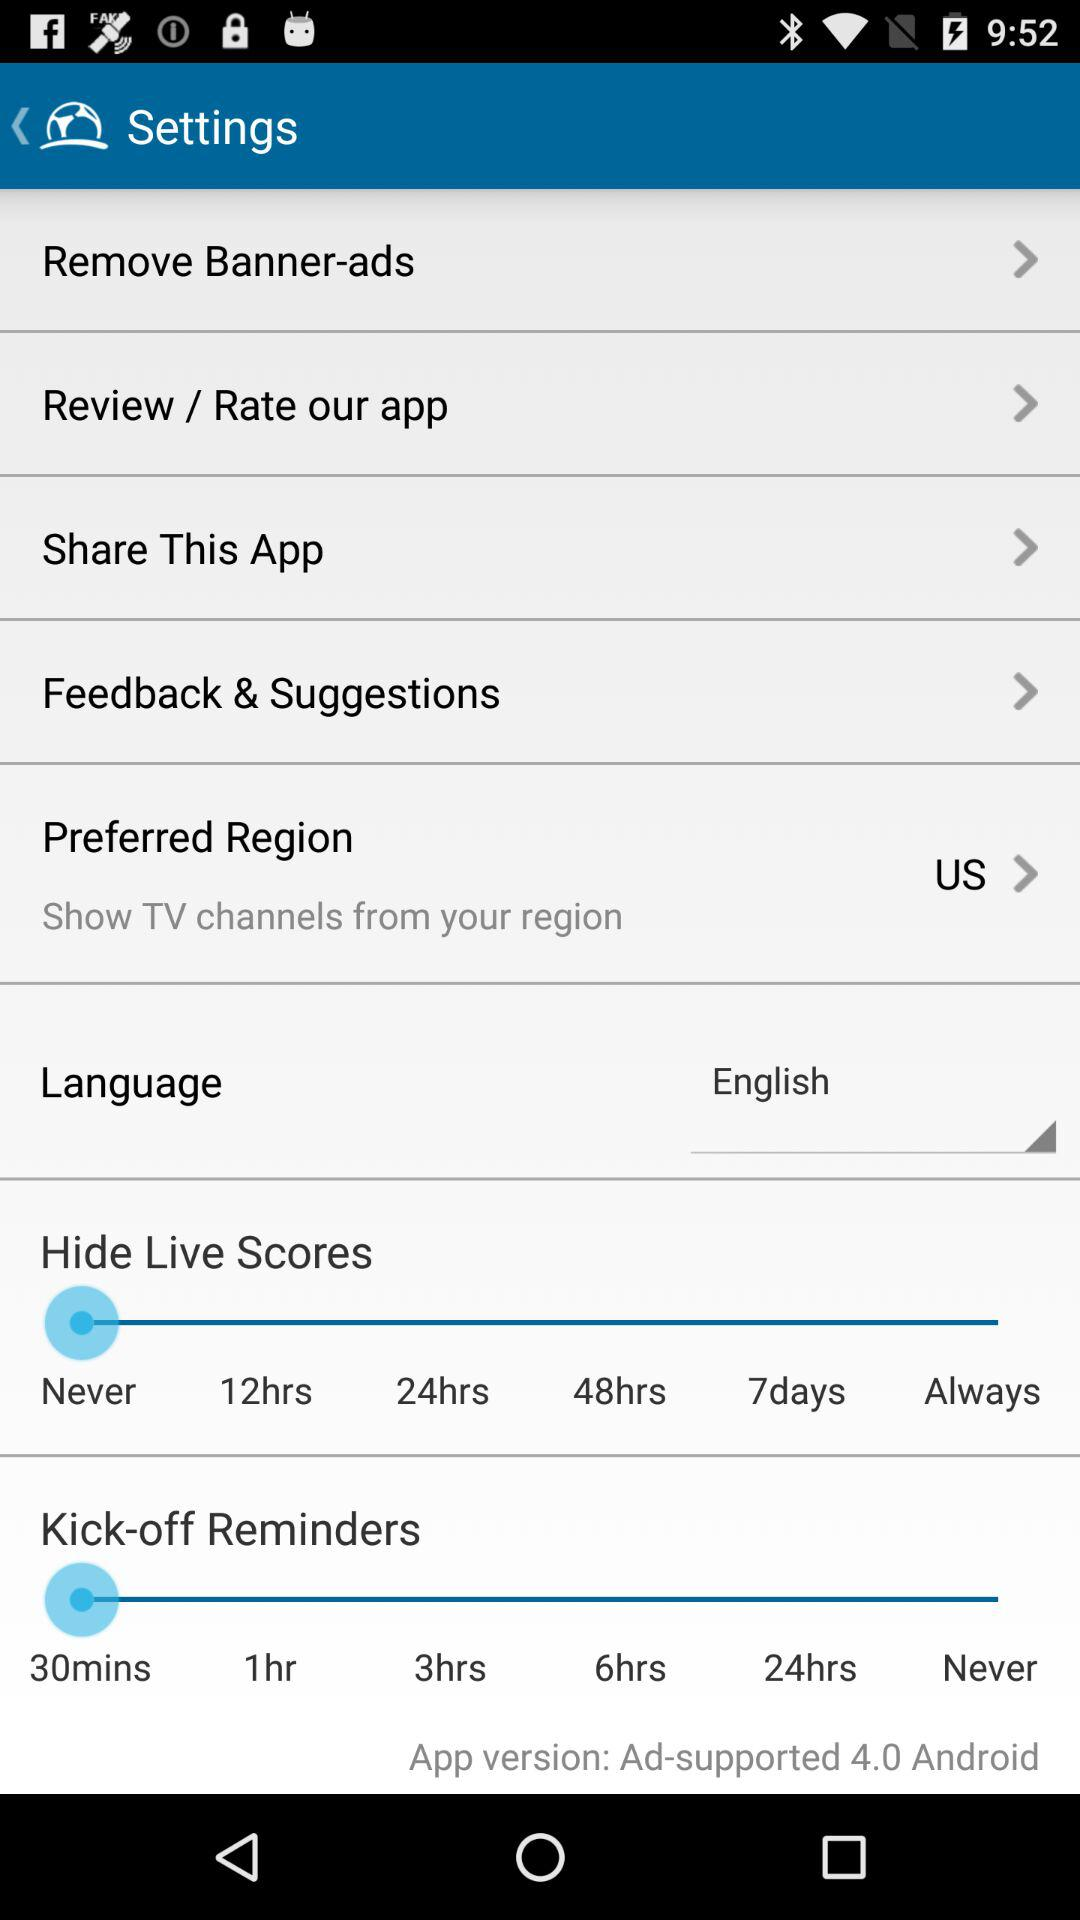Which language is selected? The selected language is English. 